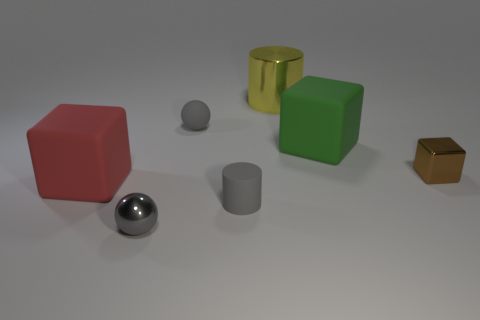Add 3 large yellow matte cubes. How many objects exist? 10 Subtract all cylinders. How many objects are left? 5 Subtract 1 brown blocks. How many objects are left? 6 Subtract all small gray shiny blocks. Subtract all large objects. How many objects are left? 4 Add 1 gray shiny balls. How many gray shiny balls are left? 2 Add 6 tiny brown metallic cubes. How many tiny brown metallic cubes exist? 7 